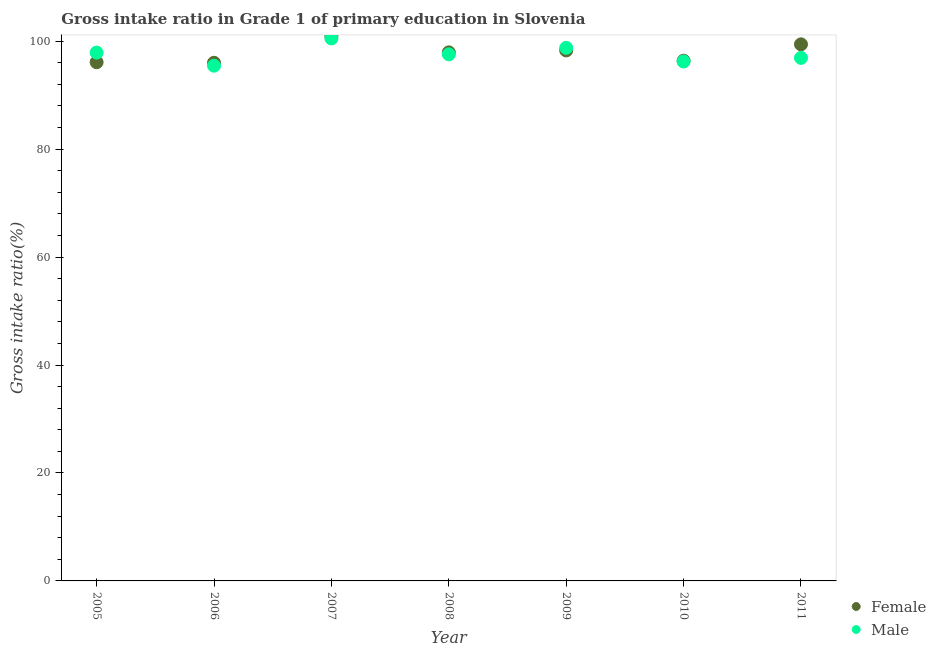How many different coloured dotlines are there?
Give a very brief answer. 2. What is the gross intake ratio(female) in 2005?
Your response must be concise. 96.11. Across all years, what is the maximum gross intake ratio(female)?
Your answer should be compact. 100.91. Across all years, what is the minimum gross intake ratio(male)?
Offer a terse response. 95.47. In which year was the gross intake ratio(male) maximum?
Keep it short and to the point. 2007. In which year was the gross intake ratio(male) minimum?
Provide a succinct answer. 2006. What is the total gross intake ratio(female) in the graph?
Ensure brevity in your answer.  685.07. What is the difference between the gross intake ratio(female) in 2005 and that in 2009?
Make the answer very short. -2.19. What is the difference between the gross intake ratio(male) in 2011 and the gross intake ratio(female) in 2008?
Offer a terse response. -1.02. What is the average gross intake ratio(male) per year?
Offer a very short reply. 97.63. In the year 2009, what is the difference between the gross intake ratio(female) and gross intake ratio(male)?
Give a very brief answer. -0.48. What is the ratio of the gross intake ratio(female) in 2009 to that in 2011?
Make the answer very short. 0.99. Is the gross intake ratio(male) in 2007 less than that in 2010?
Provide a short and direct response. No. What is the difference between the highest and the second highest gross intake ratio(male)?
Your response must be concise. 1.74. What is the difference between the highest and the lowest gross intake ratio(male)?
Make the answer very short. 5.05. Is the sum of the gross intake ratio(female) in 2005 and 2006 greater than the maximum gross intake ratio(male) across all years?
Give a very brief answer. Yes. Is the gross intake ratio(male) strictly greater than the gross intake ratio(female) over the years?
Keep it short and to the point. No. Is the gross intake ratio(female) strictly less than the gross intake ratio(male) over the years?
Provide a short and direct response. No. How many dotlines are there?
Offer a terse response. 2. Does the graph contain any zero values?
Provide a succinct answer. No. Where does the legend appear in the graph?
Offer a terse response. Bottom right. How many legend labels are there?
Offer a very short reply. 2. What is the title of the graph?
Keep it short and to the point. Gross intake ratio in Grade 1 of primary education in Slovenia. Does "Nitrous oxide" appear as one of the legend labels in the graph?
Give a very brief answer. No. What is the label or title of the X-axis?
Your answer should be very brief. Year. What is the label or title of the Y-axis?
Give a very brief answer. Gross intake ratio(%). What is the Gross intake ratio(%) in Female in 2005?
Provide a short and direct response. 96.11. What is the Gross intake ratio(%) in Male in 2005?
Provide a short and direct response. 97.89. What is the Gross intake ratio(%) of Female in 2006?
Offer a terse response. 96.01. What is the Gross intake ratio(%) in Male in 2006?
Offer a terse response. 95.47. What is the Gross intake ratio(%) of Female in 2007?
Keep it short and to the point. 100.91. What is the Gross intake ratio(%) in Male in 2007?
Your answer should be very brief. 100.52. What is the Gross intake ratio(%) in Female in 2008?
Make the answer very short. 97.94. What is the Gross intake ratio(%) in Male in 2008?
Ensure brevity in your answer.  97.57. What is the Gross intake ratio(%) in Female in 2009?
Ensure brevity in your answer.  98.3. What is the Gross intake ratio(%) of Male in 2009?
Make the answer very short. 98.77. What is the Gross intake ratio(%) of Female in 2010?
Give a very brief answer. 96.39. What is the Gross intake ratio(%) in Male in 2010?
Offer a very short reply. 96.25. What is the Gross intake ratio(%) in Female in 2011?
Provide a short and direct response. 99.43. What is the Gross intake ratio(%) in Male in 2011?
Your answer should be very brief. 96.91. Across all years, what is the maximum Gross intake ratio(%) in Female?
Provide a succinct answer. 100.91. Across all years, what is the maximum Gross intake ratio(%) in Male?
Provide a succinct answer. 100.52. Across all years, what is the minimum Gross intake ratio(%) of Female?
Give a very brief answer. 96.01. Across all years, what is the minimum Gross intake ratio(%) of Male?
Provide a succinct answer. 95.47. What is the total Gross intake ratio(%) of Female in the graph?
Provide a short and direct response. 685.07. What is the total Gross intake ratio(%) in Male in the graph?
Offer a terse response. 683.39. What is the difference between the Gross intake ratio(%) in Female in 2005 and that in 2006?
Your answer should be very brief. 0.1. What is the difference between the Gross intake ratio(%) of Male in 2005 and that in 2006?
Offer a very short reply. 2.42. What is the difference between the Gross intake ratio(%) of Female in 2005 and that in 2007?
Your answer should be very brief. -4.8. What is the difference between the Gross intake ratio(%) in Male in 2005 and that in 2007?
Give a very brief answer. -2.63. What is the difference between the Gross intake ratio(%) in Female in 2005 and that in 2008?
Offer a very short reply. -1.83. What is the difference between the Gross intake ratio(%) of Male in 2005 and that in 2008?
Your answer should be very brief. 0.32. What is the difference between the Gross intake ratio(%) in Female in 2005 and that in 2009?
Make the answer very short. -2.19. What is the difference between the Gross intake ratio(%) in Male in 2005 and that in 2009?
Offer a terse response. -0.88. What is the difference between the Gross intake ratio(%) in Female in 2005 and that in 2010?
Keep it short and to the point. -0.28. What is the difference between the Gross intake ratio(%) in Male in 2005 and that in 2010?
Your answer should be compact. 1.64. What is the difference between the Gross intake ratio(%) in Female in 2005 and that in 2011?
Your answer should be compact. -3.32. What is the difference between the Gross intake ratio(%) in Male in 2005 and that in 2011?
Provide a succinct answer. 0.98. What is the difference between the Gross intake ratio(%) in Female in 2006 and that in 2007?
Ensure brevity in your answer.  -4.9. What is the difference between the Gross intake ratio(%) of Male in 2006 and that in 2007?
Offer a very short reply. -5.05. What is the difference between the Gross intake ratio(%) of Female in 2006 and that in 2008?
Your answer should be compact. -1.93. What is the difference between the Gross intake ratio(%) in Male in 2006 and that in 2008?
Offer a very short reply. -2.1. What is the difference between the Gross intake ratio(%) of Female in 2006 and that in 2009?
Make the answer very short. -2.29. What is the difference between the Gross intake ratio(%) of Male in 2006 and that in 2009?
Provide a succinct answer. -3.3. What is the difference between the Gross intake ratio(%) in Female in 2006 and that in 2010?
Your answer should be very brief. -0.38. What is the difference between the Gross intake ratio(%) of Male in 2006 and that in 2010?
Give a very brief answer. -0.78. What is the difference between the Gross intake ratio(%) in Female in 2006 and that in 2011?
Your response must be concise. -3.42. What is the difference between the Gross intake ratio(%) of Male in 2006 and that in 2011?
Give a very brief answer. -1.44. What is the difference between the Gross intake ratio(%) of Female in 2007 and that in 2008?
Keep it short and to the point. 2.97. What is the difference between the Gross intake ratio(%) in Male in 2007 and that in 2008?
Your response must be concise. 2.95. What is the difference between the Gross intake ratio(%) in Female in 2007 and that in 2009?
Keep it short and to the point. 2.61. What is the difference between the Gross intake ratio(%) in Male in 2007 and that in 2009?
Your response must be concise. 1.74. What is the difference between the Gross intake ratio(%) in Female in 2007 and that in 2010?
Your answer should be very brief. 4.52. What is the difference between the Gross intake ratio(%) of Male in 2007 and that in 2010?
Provide a short and direct response. 4.27. What is the difference between the Gross intake ratio(%) of Female in 2007 and that in 2011?
Provide a succinct answer. 1.48. What is the difference between the Gross intake ratio(%) of Male in 2007 and that in 2011?
Ensure brevity in your answer.  3.6. What is the difference between the Gross intake ratio(%) of Female in 2008 and that in 2009?
Your answer should be very brief. -0.36. What is the difference between the Gross intake ratio(%) of Male in 2008 and that in 2009?
Your response must be concise. -1.2. What is the difference between the Gross intake ratio(%) in Female in 2008 and that in 2010?
Provide a short and direct response. 1.55. What is the difference between the Gross intake ratio(%) in Male in 2008 and that in 2010?
Provide a succinct answer. 1.32. What is the difference between the Gross intake ratio(%) in Female in 2008 and that in 2011?
Ensure brevity in your answer.  -1.49. What is the difference between the Gross intake ratio(%) in Male in 2008 and that in 2011?
Offer a terse response. 0.66. What is the difference between the Gross intake ratio(%) of Female in 2009 and that in 2010?
Your answer should be very brief. 1.91. What is the difference between the Gross intake ratio(%) in Male in 2009 and that in 2010?
Your answer should be compact. 2.53. What is the difference between the Gross intake ratio(%) of Female in 2009 and that in 2011?
Offer a terse response. -1.13. What is the difference between the Gross intake ratio(%) of Male in 2009 and that in 2011?
Your answer should be very brief. 1.86. What is the difference between the Gross intake ratio(%) in Female in 2010 and that in 2011?
Offer a terse response. -3.04. What is the difference between the Gross intake ratio(%) of Male in 2010 and that in 2011?
Your response must be concise. -0.67. What is the difference between the Gross intake ratio(%) in Female in 2005 and the Gross intake ratio(%) in Male in 2006?
Offer a terse response. 0.64. What is the difference between the Gross intake ratio(%) of Female in 2005 and the Gross intake ratio(%) of Male in 2007?
Your answer should be very brief. -4.41. What is the difference between the Gross intake ratio(%) of Female in 2005 and the Gross intake ratio(%) of Male in 2008?
Ensure brevity in your answer.  -1.46. What is the difference between the Gross intake ratio(%) in Female in 2005 and the Gross intake ratio(%) in Male in 2009?
Offer a terse response. -2.66. What is the difference between the Gross intake ratio(%) of Female in 2005 and the Gross intake ratio(%) of Male in 2010?
Your response must be concise. -0.14. What is the difference between the Gross intake ratio(%) in Female in 2005 and the Gross intake ratio(%) in Male in 2011?
Your answer should be compact. -0.81. What is the difference between the Gross intake ratio(%) in Female in 2006 and the Gross intake ratio(%) in Male in 2007?
Provide a succinct answer. -4.51. What is the difference between the Gross intake ratio(%) in Female in 2006 and the Gross intake ratio(%) in Male in 2008?
Provide a succinct answer. -1.56. What is the difference between the Gross intake ratio(%) in Female in 2006 and the Gross intake ratio(%) in Male in 2009?
Provide a succinct answer. -2.77. What is the difference between the Gross intake ratio(%) in Female in 2006 and the Gross intake ratio(%) in Male in 2010?
Offer a very short reply. -0.24. What is the difference between the Gross intake ratio(%) in Female in 2006 and the Gross intake ratio(%) in Male in 2011?
Keep it short and to the point. -0.91. What is the difference between the Gross intake ratio(%) of Female in 2007 and the Gross intake ratio(%) of Male in 2008?
Give a very brief answer. 3.33. What is the difference between the Gross intake ratio(%) in Female in 2007 and the Gross intake ratio(%) in Male in 2009?
Your answer should be compact. 2.13. What is the difference between the Gross intake ratio(%) of Female in 2007 and the Gross intake ratio(%) of Male in 2010?
Your response must be concise. 4.66. What is the difference between the Gross intake ratio(%) in Female in 2007 and the Gross intake ratio(%) in Male in 2011?
Your response must be concise. 3.99. What is the difference between the Gross intake ratio(%) in Female in 2008 and the Gross intake ratio(%) in Male in 2009?
Your response must be concise. -0.84. What is the difference between the Gross intake ratio(%) of Female in 2008 and the Gross intake ratio(%) of Male in 2010?
Offer a terse response. 1.69. What is the difference between the Gross intake ratio(%) of Female in 2008 and the Gross intake ratio(%) of Male in 2011?
Ensure brevity in your answer.  1.02. What is the difference between the Gross intake ratio(%) in Female in 2009 and the Gross intake ratio(%) in Male in 2010?
Keep it short and to the point. 2.05. What is the difference between the Gross intake ratio(%) of Female in 2009 and the Gross intake ratio(%) of Male in 2011?
Make the answer very short. 1.38. What is the difference between the Gross intake ratio(%) in Female in 2010 and the Gross intake ratio(%) in Male in 2011?
Offer a very short reply. -0.53. What is the average Gross intake ratio(%) of Female per year?
Provide a succinct answer. 97.87. What is the average Gross intake ratio(%) in Male per year?
Provide a succinct answer. 97.63. In the year 2005, what is the difference between the Gross intake ratio(%) of Female and Gross intake ratio(%) of Male?
Provide a succinct answer. -1.78. In the year 2006, what is the difference between the Gross intake ratio(%) of Female and Gross intake ratio(%) of Male?
Offer a very short reply. 0.54. In the year 2007, what is the difference between the Gross intake ratio(%) in Female and Gross intake ratio(%) in Male?
Provide a short and direct response. 0.39. In the year 2008, what is the difference between the Gross intake ratio(%) of Female and Gross intake ratio(%) of Male?
Offer a terse response. 0.37. In the year 2009, what is the difference between the Gross intake ratio(%) in Female and Gross intake ratio(%) in Male?
Give a very brief answer. -0.48. In the year 2010, what is the difference between the Gross intake ratio(%) of Female and Gross intake ratio(%) of Male?
Give a very brief answer. 0.14. In the year 2011, what is the difference between the Gross intake ratio(%) of Female and Gross intake ratio(%) of Male?
Offer a very short reply. 2.51. What is the ratio of the Gross intake ratio(%) in Male in 2005 to that in 2006?
Offer a terse response. 1.03. What is the ratio of the Gross intake ratio(%) in Female in 2005 to that in 2007?
Keep it short and to the point. 0.95. What is the ratio of the Gross intake ratio(%) of Male in 2005 to that in 2007?
Keep it short and to the point. 0.97. What is the ratio of the Gross intake ratio(%) in Female in 2005 to that in 2008?
Provide a succinct answer. 0.98. What is the ratio of the Gross intake ratio(%) of Female in 2005 to that in 2009?
Ensure brevity in your answer.  0.98. What is the ratio of the Gross intake ratio(%) in Female in 2005 to that in 2010?
Offer a terse response. 1. What is the ratio of the Gross intake ratio(%) of Male in 2005 to that in 2010?
Your response must be concise. 1.02. What is the ratio of the Gross intake ratio(%) in Female in 2005 to that in 2011?
Offer a very short reply. 0.97. What is the ratio of the Gross intake ratio(%) in Female in 2006 to that in 2007?
Make the answer very short. 0.95. What is the ratio of the Gross intake ratio(%) in Male in 2006 to that in 2007?
Your answer should be compact. 0.95. What is the ratio of the Gross intake ratio(%) of Female in 2006 to that in 2008?
Make the answer very short. 0.98. What is the ratio of the Gross intake ratio(%) in Male in 2006 to that in 2008?
Keep it short and to the point. 0.98. What is the ratio of the Gross intake ratio(%) of Female in 2006 to that in 2009?
Your response must be concise. 0.98. What is the ratio of the Gross intake ratio(%) in Male in 2006 to that in 2009?
Offer a very short reply. 0.97. What is the ratio of the Gross intake ratio(%) in Female in 2006 to that in 2010?
Your answer should be compact. 1. What is the ratio of the Gross intake ratio(%) of Female in 2006 to that in 2011?
Give a very brief answer. 0.97. What is the ratio of the Gross intake ratio(%) in Male in 2006 to that in 2011?
Give a very brief answer. 0.99. What is the ratio of the Gross intake ratio(%) in Female in 2007 to that in 2008?
Offer a terse response. 1.03. What is the ratio of the Gross intake ratio(%) of Male in 2007 to that in 2008?
Your answer should be compact. 1.03. What is the ratio of the Gross intake ratio(%) in Female in 2007 to that in 2009?
Offer a terse response. 1.03. What is the ratio of the Gross intake ratio(%) in Male in 2007 to that in 2009?
Make the answer very short. 1.02. What is the ratio of the Gross intake ratio(%) in Female in 2007 to that in 2010?
Provide a short and direct response. 1.05. What is the ratio of the Gross intake ratio(%) in Male in 2007 to that in 2010?
Your response must be concise. 1.04. What is the ratio of the Gross intake ratio(%) in Female in 2007 to that in 2011?
Your answer should be compact. 1.01. What is the ratio of the Gross intake ratio(%) in Male in 2007 to that in 2011?
Your response must be concise. 1.04. What is the ratio of the Gross intake ratio(%) in Male in 2008 to that in 2009?
Your answer should be very brief. 0.99. What is the ratio of the Gross intake ratio(%) in Female in 2008 to that in 2010?
Your answer should be compact. 1.02. What is the ratio of the Gross intake ratio(%) of Male in 2008 to that in 2010?
Provide a short and direct response. 1.01. What is the ratio of the Gross intake ratio(%) of Male in 2008 to that in 2011?
Give a very brief answer. 1.01. What is the ratio of the Gross intake ratio(%) of Female in 2009 to that in 2010?
Offer a terse response. 1.02. What is the ratio of the Gross intake ratio(%) in Male in 2009 to that in 2010?
Offer a terse response. 1.03. What is the ratio of the Gross intake ratio(%) of Male in 2009 to that in 2011?
Give a very brief answer. 1.02. What is the ratio of the Gross intake ratio(%) in Female in 2010 to that in 2011?
Give a very brief answer. 0.97. What is the difference between the highest and the second highest Gross intake ratio(%) of Female?
Make the answer very short. 1.48. What is the difference between the highest and the second highest Gross intake ratio(%) in Male?
Your answer should be compact. 1.74. What is the difference between the highest and the lowest Gross intake ratio(%) in Female?
Make the answer very short. 4.9. What is the difference between the highest and the lowest Gross intake ratio(%) of Male?
Keep it short and to the point. 5.05. 